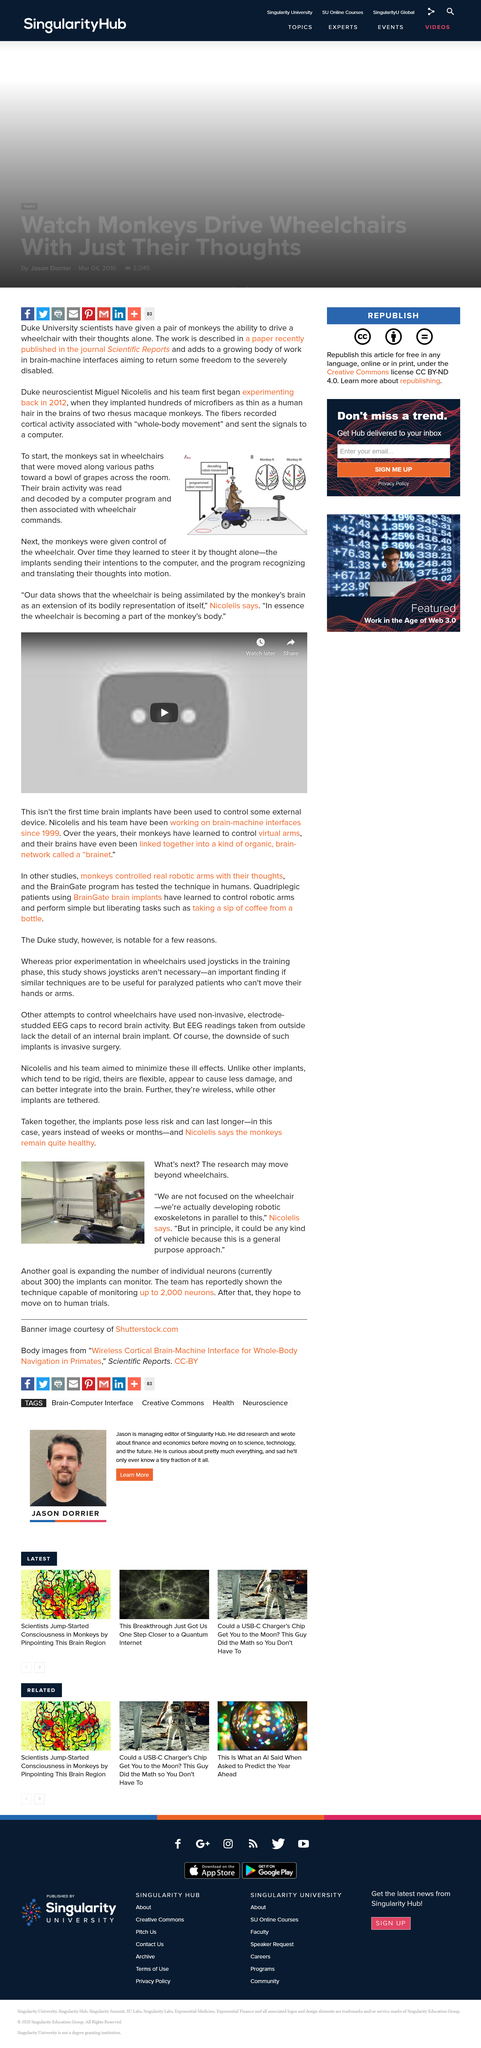Draw attention to some important aspects in this diagram. According to the information provided, it is indicated that monkeys are being used within a specific test, and a particular animal is being utilized in this experiment. The scientific report had the purpose of returning some freedom to severely disabled individuals. In the story, the monkey learned to steer the wheelchair by thoughts alone through the use of implants that transmitted the monkey's intentions to a computer, which then translated them into motion. The article mentions a trial that is currently being conducted on humans, and the authors hope to move the technology to human trials in the future. Miguel Nicolelis used microfibers, a wheelchair, and a computer to conduct his experiment. 